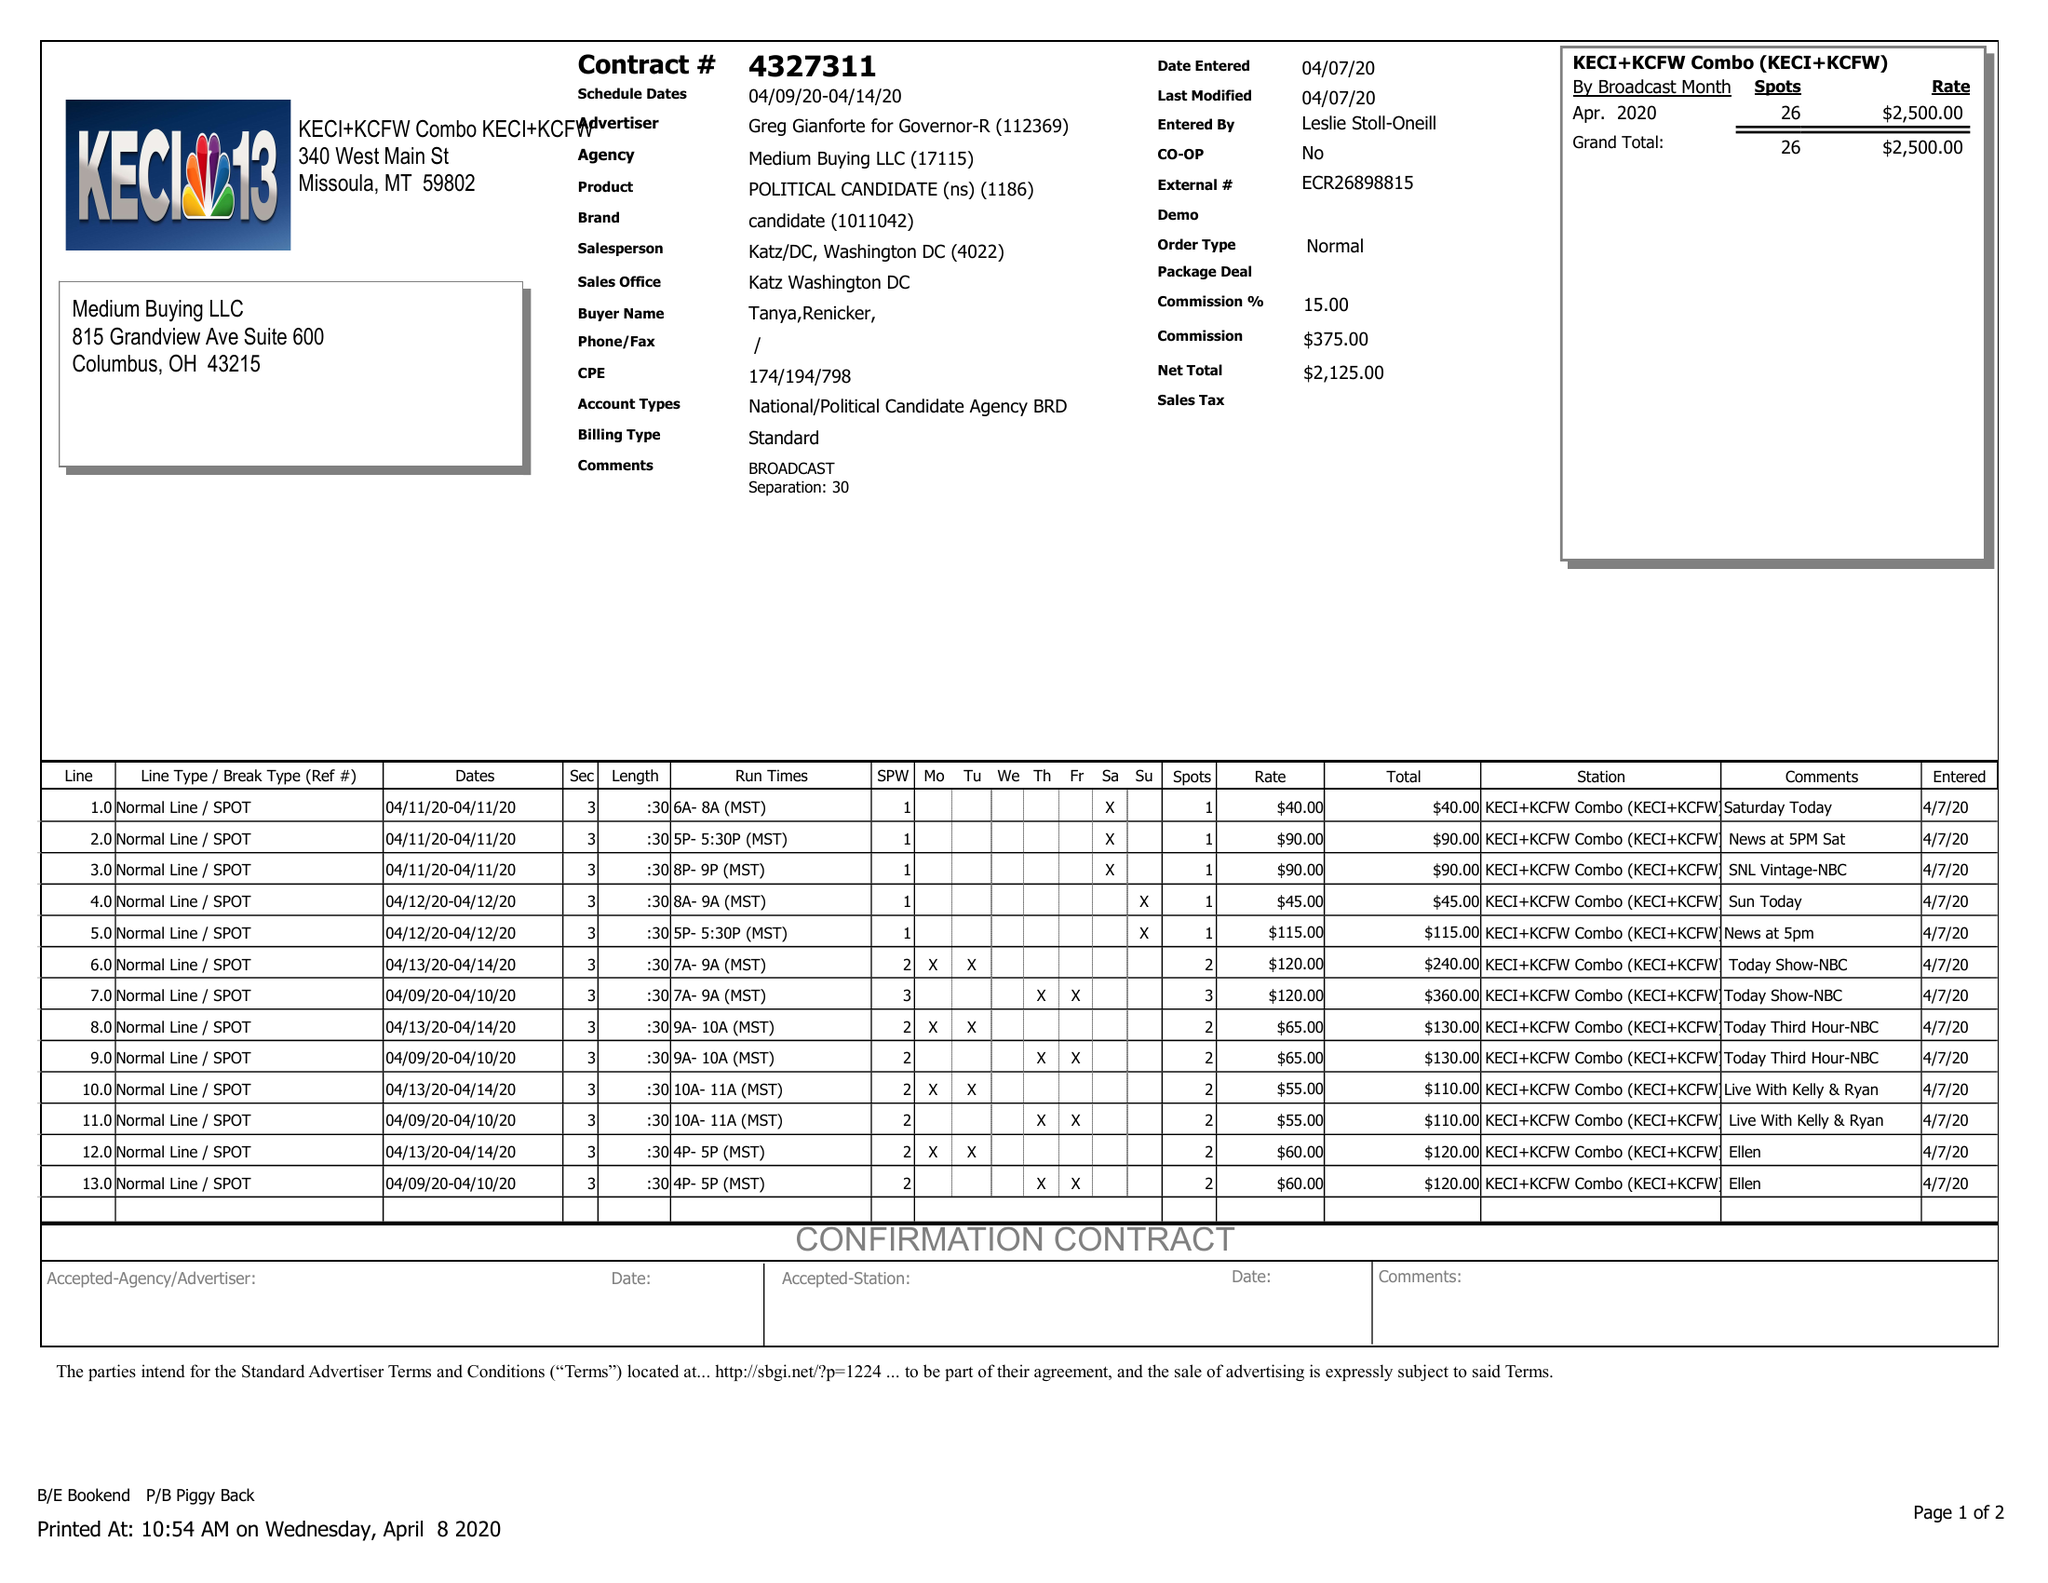What is the value for the advertiser?
Answer the question using a single word or phrase. GREG GIANFORTE FOR GOVERNOR-R 